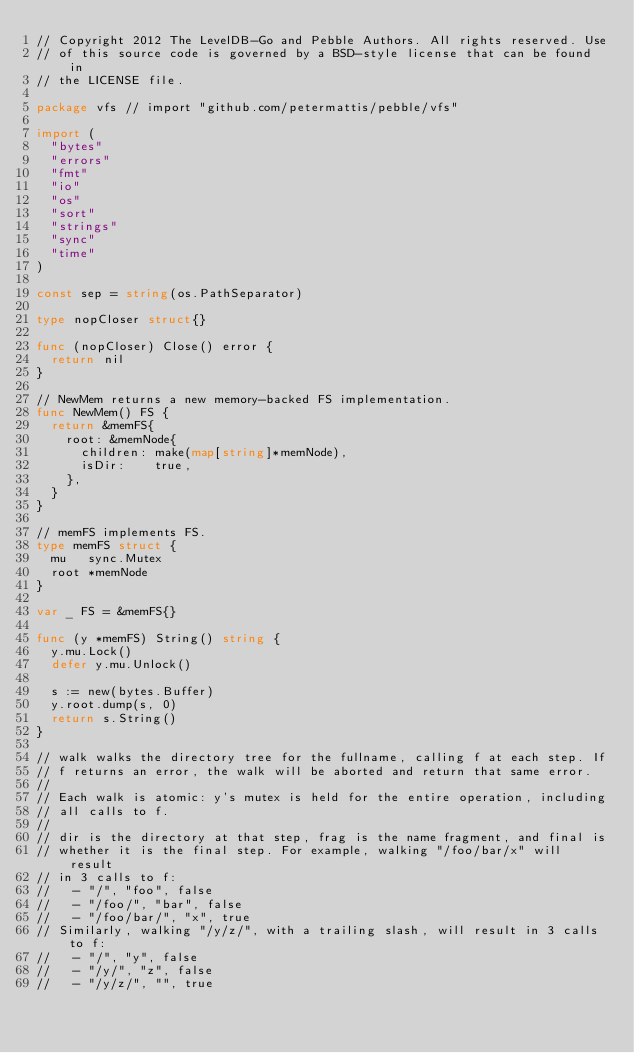<code> <loc_0><loc_0><loc_500><loc_500><_Go_>// Copyright 2012 The LevelDB-Go and Pebble Authors. All rights reserved. Use
// of this source code is governed by a BSD-style license that can be found in
// the LICENSE file.

package vfs // import "github.com/petermattis/pebble/vfs"

import (
	"bytes"
	"errors"
	"fmt"
	"io"
	"os"
	"sort"
	"strings"
	"sync"
	"time"
)

const sep = string(os.PathSeparator)

type nopCloser struct{}

func (nopCloser) Close() error {
	return nil
}

// NewMem returns a new memory-backed FS implementation.
func NewMem() FS {
	return &memFS{
		root: &memNode{
			children: make(map[string]*memNode),
			isDir:    true,
		},
	}
}

// memFS implements FS.
type memFS struct {
	mu   sync.Mutex
	root *memNode
}

var _ FS = &memFS{}

func (y *memFS) String() string {
	y.mu.Lock()
	defer y.mu.Unlock()

	s := new(bytes.Buffer)
	y.root.dump(s, 0)
	return s.String()
}

// walk walks the directory tree for the fullname, calling f at each step. If
// f returns an error, the walk will be aborted and return that same error.
//
// Each walk is atomic: y's mutex is held for the entire operation, including
// all calls to f.
//
// dir is the directory at that step, frag is the name fragment, and final is
// whether it is the final step. For example, walking "/foo/bar/x" will result
// in 3 calls to f:
//   - "/", "foo", false
//   - "/foo/", "bar", false
//   - "/foo/bar/", "x", true
// Similarly, walking "/y/z/", with a trailing slash, will result in 3 calls to f:
//   - "/", "y", false
//   - "/y/", "z", false
//   - "/y/z/", "", true</code> 